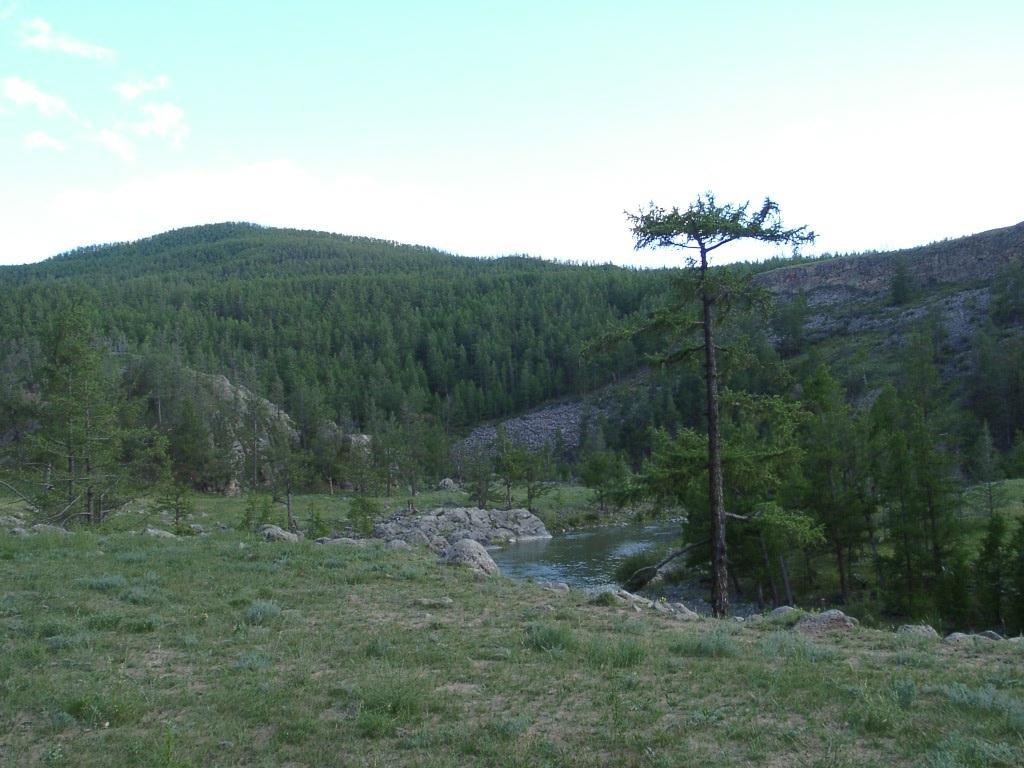Please provide a concise description of this image. In the image I can see the grass, the water and trees. In the background I can see the sky. 